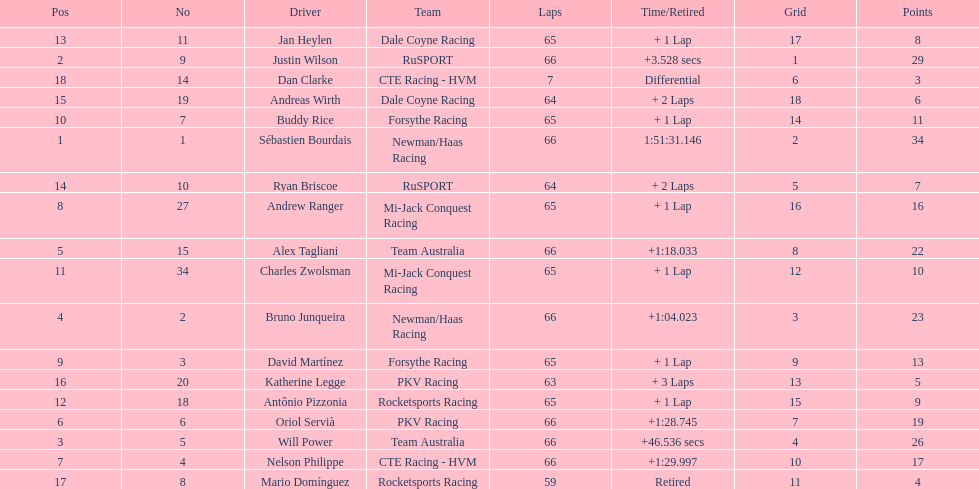At the 2006 gran premio telmex, who finished last? Dan Clarke. 